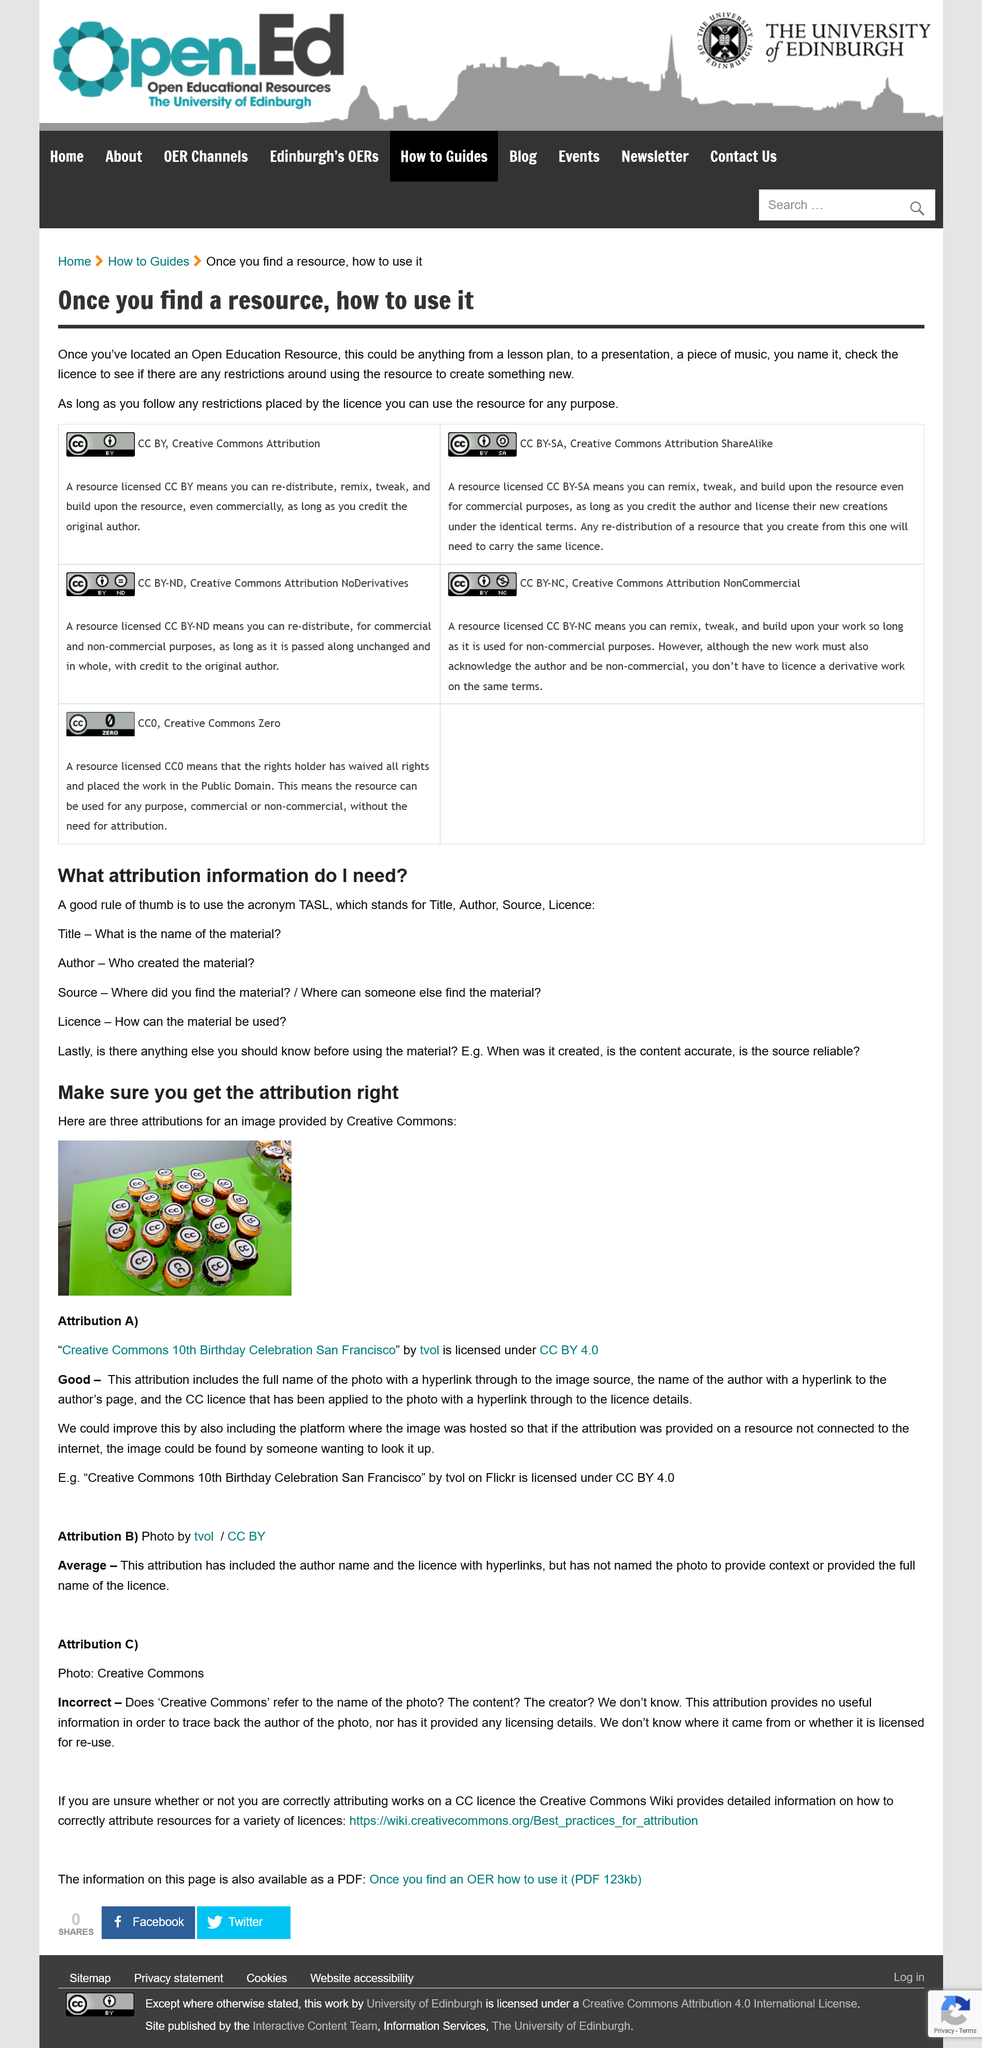Draw attention to some important aspects in this diagram. The acronym TASL stands for Title, Author, Source, and License, which are essential components of a digital resource that provide a detailed description of the information it contains. Attribution B is rated as average. Open Education Resources can be used for anything, as long as any restrictions imposed by the license used are followed. Attribution C is rated as incorrect. It is crucial to also consider when the material was created, its accuracy, and the reliability of the source before using it. 